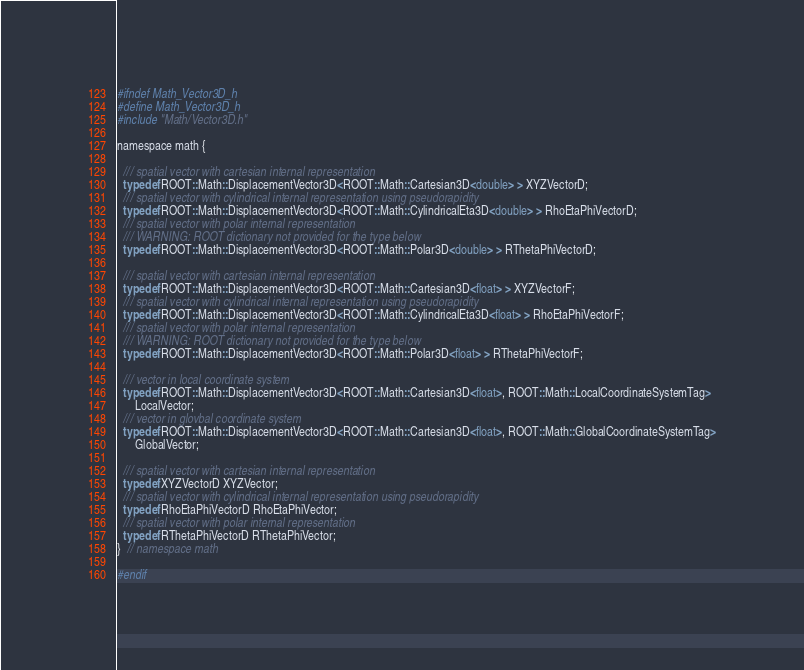Convert code to text. <code><loc_0><loc_0><loc_500><loc_500><_C_>#ifndef Math_Vector3D_h
#define Math_Vector3D_h
#include "Math/Vector3D.h"

namespace math {

  /// spatial vector with cartesian internal representation
  typedef ROOT::Math::DisplacementVector3D<ROOT::Math::Cartesian3D<double> > XYZVectorD;
  /// spatial vector with cylindrical internal representation using pseudorapidity
  typedef ROOT::Math::DisplacementVector3D<ROOT::Math::CylindricalEta3D<double> > RhoEtaPhiVectorD;
  /// spatial vector with polar internal representation
  /// WARNING: ROOT dictionary not provided for the type below
  typedef ROOT::Math::DisplacementVector3D<ROOT::Math::Polar3D<double> > RThetaPhiVectorD;

  /// spatial vector with cartesian internal representation
  typedef ROOT::Math::DisplacementVector3D<ROOT::Math::Cartesian3D<float> > XYZVectorF;
  /// spatial vector with cylindrical internal representation using pseudorapidity
  typedef ROOT::Math::DisplacementVector3D<ROOT::Math::CylindricalEta3D<float> > RhoEtaPhiVectorF;
  /// spatial vector with polar internal representation
  /// WARNING: ROOT dictionary not provided for the type below
  typedef ROOT::Math::DisplacementVector3D<ROOT::Math::Polar3D<float> > RThetaPhiVectorF;

  /// vector in local coordinate system
  typedef ROOT::Math::DisplacementVector3D<ROOT::Math::Cartesian3D<float>, ROOT::Math::LocalCoordinateSystemTag>
      LocalVector;
  /// vector in glovbal coordinate system
  typedef ROOT::Math::DisplacementVector3D<ROOT::Math::Cartesian3D<float>, ROOT::Math::GlobalCoordinateSystemTag>
      GlobalVector;

  /// spatial vector with cartesian internal representation
  typedef XYZVectorD XYZVector;
  /// spatial vector with cylindrical internal representation using pseudorapidity
  typedef RhoEtaPhiVectorD RhoEtaPhiVector;
  /// spatial vector with polar internal representation
  typedef RThetaPhiVectorD RThetaPhiVector;
}  // namespace math

#endif
</code> 